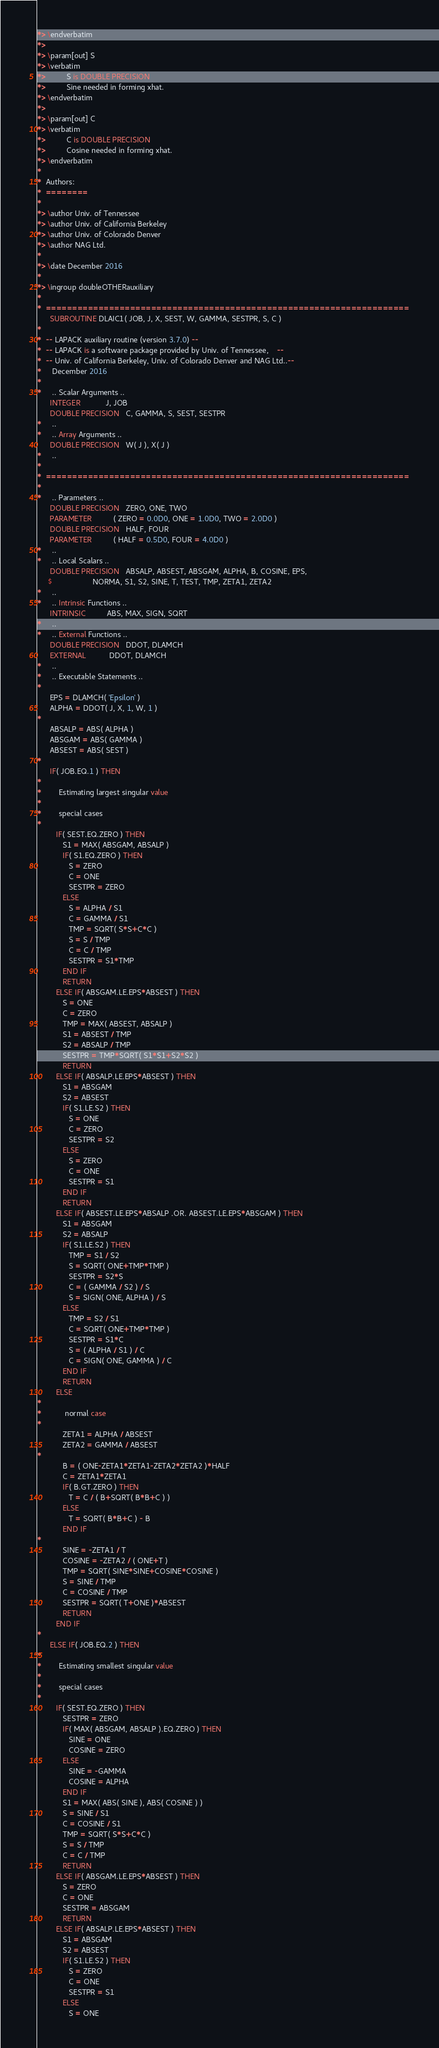Convert code to text. <code><loc_0><loc_0><loc_500><loc_500><_FORTRAN_>*> \endverbatim
*>
*> \param[out] S
*> \verbatim
*>          S is DOUBLE PRECISION
*>          Sine needed in forming xhat.
*> \endverbatim
*>
*> \param[out] C
*> \verbatim
*>          C is DOUBLE PRECISION
*>          Cosine needed in forming xhat.
*> \endverbatim
*
*  Authors:
*  ========
*
*> \author Univ. of Tennessee
*> \author Univ. of California Berkeley
*> \author Univ. of Colorado Denver
*> \author NAG Ltd.
*
*> \date December 2016
*
*> \ingroup doubleOTHERauxiliary
*
*  =====================================================================
      SUBROUTINE DLAIC1( JOB, J, X, SEST, W, GAMMA, SESTPR, S, C )
*
*  -- LAPACK auxiliary routine (version 3.7.0) --
*  -- LAPACK is a software package provided by Univ. of Tennessee,    --
*  -- Univ. of California Berkeley, Univ. of Colorado Denver and NAG Ltd..--
*     December 2016
*
*     .. Scalar Arguments ..
      INTEGER            J, JOB
      DOUBLE PRECISION   C, GAMMA, S, SEST, SESTPR
*     ..
*     .. Array Arguments ..
      DOUBLE PRECISION   W( J ), X( J )
*     ..
*
*  =====================================================================
*
*     .. Parameters ..
      DOUBLE PRECISION   ZERO, ONE, TWO
      PARAMETER          ( ZERO = 0.0D0, ONE = 1.0D0, TWO = 2.0D0 )
      DOUBLE PRECISION   HALF, FOUR
      PARAMETER          ( HALF = 0.5D0, FOUR = 4.0D0 )
*     ..
*     .. Local Scalars ..
      DOUBLE PRECISION   ABSALP, ABSEST, ABSGAM, ALPHA, B, COSINE, EPS,
     $                   NORMA, S1, S2, SINE, T, TEST, TMP, ZETA1, ZETA2
*     ..
*     .. Intrinsic Functions ..
      INTRINSIC          ABS, MAX, SIGN, SQRT
*     ..
*     .. External Functions ..
      DOUBLE PRECISION   DDOT, DLAMCH
      EXTERNAL           DDOT, DLAMCH
*     ..
*     .. Executable Statements ..
*
      EPS = DLAMCH( 'Epsilon' )
      ALPHA = DDOT( J, X, 1, W, 1 )
*
      ABSALP = ABS( ALPHA )
      ABSGAM = ABS( GAMMA )
      ABSEST = ABS( SEST )
*
      IF( JOB.EQ.1 ) THEN
*
*        Estimating largest singular value
*
*        special cases
*
         IF( SEST.EQ.ZERO ) THEN
            S1 = MAX( ABSGAM, ABSALP )
            IF( S1.EQ.ZERO ) THEN
               S = ZERO
               C = ONE
               SESTPR = ZERO
            ELSE
               S = ALPHA / S1
               C = GAMMA / S1
               TMP = SQRT( S*S+C*C )
               S = S / TMP
               C = C / TMP
               SESTPR = S1*TMP
            END IF
            RETURN
         ELSE IF( ABSGAM.LE.EPS*ABSEST ) THEN
            S = ONE
            C = ZERO
            TMP = MAX( ABSEST, ABSALP )
            S1 = ABSEST / TMP
            S2 = ABSALP / TMP
            SESTPR = TMP*SQRT( S1*S1+S2*S2 )
            RETURN
         ELSE IF( ABSALP.LE.EPS*ABSEST ) THEN
            S1 = ABSGAM
            S2 = ABSEST
            IF( S1.LE.S2 ) THEN
               S = ONE
               C = ZERO
               SESTPR = S2
            ELSE
               S = ZERO
               C = ONE
               SESTPR = S1
            END IF
            RETURN
         ELSE IF( ABSEST.LE.EPS*ABSALP .OR. ABSEST.LE.EPS*ABSGAM ) THEN
            S1 = ABSGAM
            S2 = ABSALP
            IF( S1.LE.S2 ) THEN
               TMP = S1 / S2
               S = SQRT( ONE+TMP*TMP )
               SESTPR = S2*S
               C = ( GAMMA / S2 ) / S
               S = SIGN( ONE, ALPHA ) / S
            ELSE
               TMP = S2 / S1
               C = SQRT( ONE+TMP*TMP )
               SESTPR = S1*C
               S = ( ALPHA / S1 ) / C
               C = SIGN( ONE, GAMMA ) / C
            END IF
            RETURN
         ELSE
*
*           normal case
*
            ZETA1 = ALPHA / ABSEST
            ZETA2 = GAMMA / ABSEST
*
            B = ( ONE-ZETA1*ZETA1-ZETA2*ZETA2 )*HALF
            C = ZETA1*ZETA1
            IF( B.GT.ZERO ) THEN
               T = C / ( B+SQRT( B*B+C ) )
            ELSE
               T = SQRT( B*B+C ) - B
            END IF
*
            SINE = -ZETA1 / T
            COSINE = -ZETA2 / ( ONE+T )
            TMP = SQRT( SINE*SINE+COSINE*COSINE )
            S = SINE / TMP
            C = COSINE / TMP
            SESTPR = SQRT( T+ONE )*ABSEST
            RETURN
         END IF
*
      ELSE IF( JOB.EQ.2 ) THEN
*
*        Estimating smallest singular value
*
*        special cases
*
         IF( SEST.EQ.ZERO ) THEN
            SESTPR = ZERO
            IF( MAX( ABSGAM, ABSALP ).EQ.ZERO ) THEN
               SINE = ONE
               COSINE = ZERO
            ELSE
               SINE = -GAMMA
               COSINE = ALPHA
            END IF
            S1 = MAX( ABS( SINE ), ABS( COSINE ) )
            S = SINE / S1
            C = COSINE / S1
            TMP = SQRT( S*S+C*C )
            S = S / TMP
            C = C / TMP
            RETURN
         ELSE IF( ABSGAM.LE.EPS*ABSEST ) THEN
            S = ZERO
            C = ONE
            SESTPR = ABSGAM
            RETURN
         ELSE IF( ABSALP.LE.EPS*ABSEST ) THEN
            S1 = ABSGAM
            S2 = ABSEST
            IF( S1.LE.S2 ) THEN
               S = ZERO
               C = ONE
               SESTPR = S1
            ELSE
               S = ONE</code> 